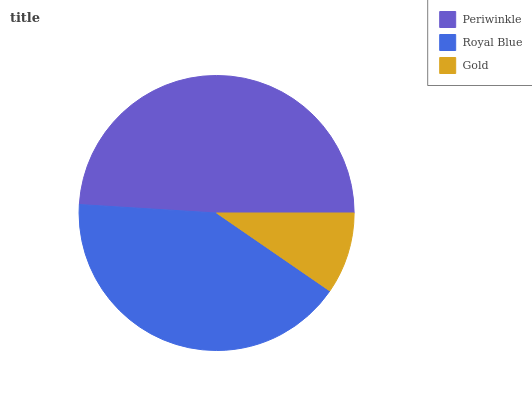Is Gold the minimum?
Answer yes or no. Yes. Is Periwinkle the maximum?
Answer yes or no. Yes. Is Royal Blue the minimum?
Answer yes or no. No. Is Royal Blue the maximum?
Answer yes or no. No. Is Periwinkle greater than Royal Blue?
Answer yes or no. Yes. Is Royal Blue less than Periwinkle?
Answer yes or no. Yes. Is Royal Blue greater than Periwinkle?
Answer yes or no. No. Is Periwinkle less than Royal Blue?
Answer yes or no. No. Is Royal Blue the high median?
Answer yes or no. Yes. Is Royal Blue the low median?
Answer yes or no. Yes. Is Periwinkle the high median?
Answer yes or no. No. Is Periwinkle the low median?
Answer yes or no. No. 